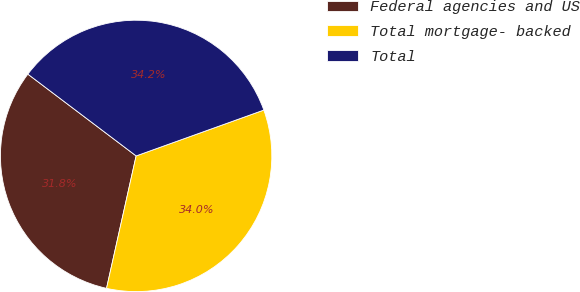<chart> <loc_0><loc_0><loc_500><loc_500><pie_chart><fcel>Federal agencies and US<fcel>Total mortgage- backed<fcel>Total<nl><fcel>31.8%<fcel>33.99%<fcel>34.22%<nl></chart> 